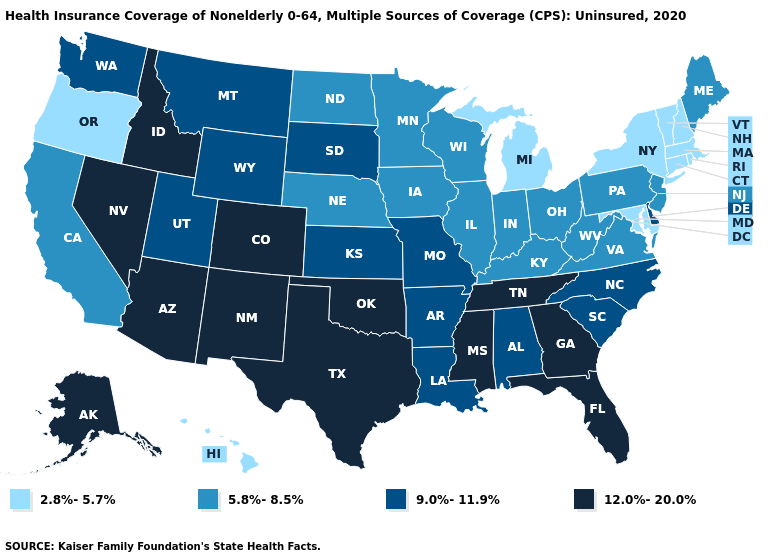Name the states that have a value in the range 5.8%-8.5%?
Answer briefly. California, Illinois, Indiana, Iowa, Kentucky, Maine, Minnesota, Nebraska, New Jersey, North Dakota, Ohio, Pennsylvania, Virginia, West Virginia, Wisconsin. What is the value of New Jersey?
Write a very short answer. 5.8%-8.5%. Name the states that have a value in the range 5.8%-8.5%?
Be succinct. California, Illinois, Indiana, Iowa, Kentucky, Maine, Minnesota, Nebraska, New Jersey, North Dakota, Ohio, Pennsylvania, Virginia, West Virginia, Wisconsin. What is the value of Georgia?
Concise answer only. 12.0%-20.0%. Does the map have missing data?
Answer briefly. No. What is the value of Nebraska?
Be succinct. 5.8%-8.5%. Among the states that border Alabama , which have the highest value?
Answer briefly. Florida, Georgia, Mississippi, Tennessee. Which states hav the highest value in the West?
Short answer required. Alaska, Arizona, Colorado, Idaho, Nevada, New Mexico. What is the lowest value in the Northeast?
Quick response, please. 2.8%-5.7%. What is the value of North Carolina?
Write a very short answer. 9.0%-11.9%. What is the value of North Carolina?
Short answer required. 9.0%-11.9%. Does Hawaii have the lowest value in the West?
Write a very short answer. Yes. Which states have the lowest value in the West?
Be succinct. Hawaii, Oregon. Does Oregon have the lowest value in the West?
Answer briefly. Yes. Does Tennessee have the same value as New Mexico?
Give a very brief answer. Yes. 